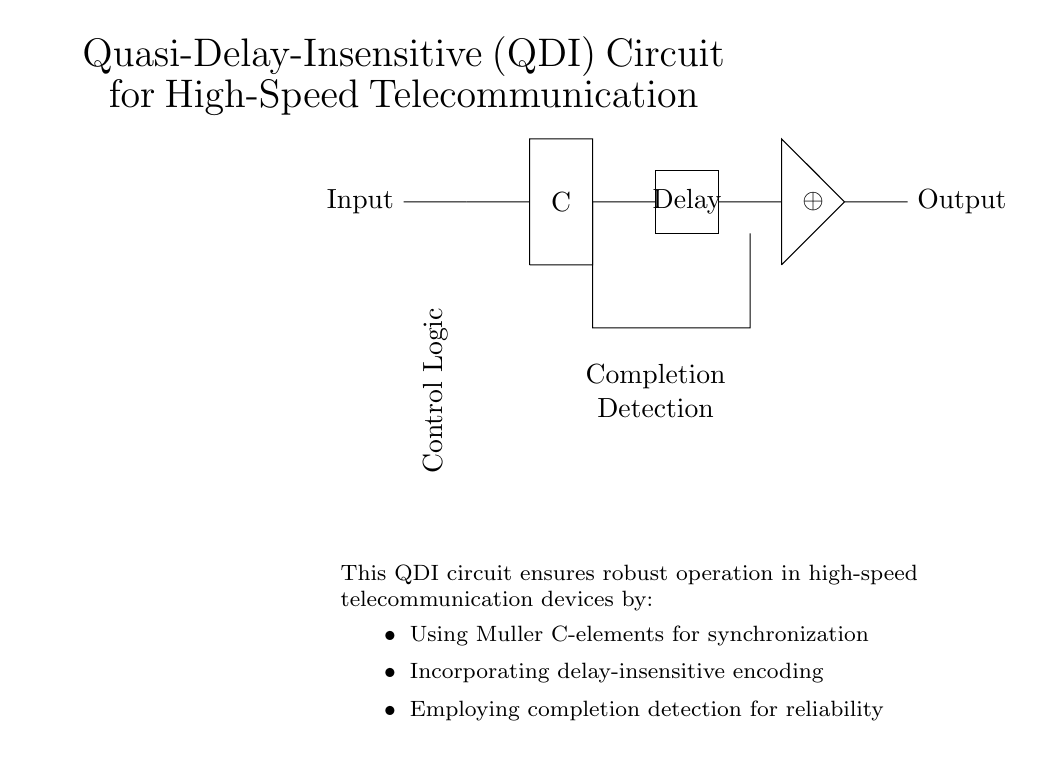What is the primary function of the Muller C-element in this circuit? The Muller C-element acts as a synchronization point for the circuit. It ensures that the output only changes when all inputs are stable, providing smooth operation in asynchronous environments.
Answer: Synchronization What type of gate is used in the circuit? The circuit employs an XOR gate, which is indicated by the symbol seen between the delay and output. This type of gate is often used for comparison or toggle operations in digital logic circuits.
Answer: XOR What is the role of the 'Delay' element in the circuit? The 'Delay' element is responsible for introducing a time delay in the signal path, ensuring that signals can propagate without causing race conditions, which is crucial in high-speed communication.
Answer: Time delay How many main components are clearly identified in the circuit? The diagram indicates three key components: the Muller C-element, the Delay element, and the XOR gate, each performing specific functions within the overall operation of the circuit.
Answer: Three What is the purpose of the feedback path in this QDI circuit? The feedback path is vital for completion detection and helps in stabilizing the state of the circuit, ensuring that transitions are properly managed, and allowing the system to confirm when operations are complete.
Answer: Completion detection Which connection represents the Input in the circuit? The circuit diagram starts with the line that feeds from the left side labeled 'Input,' connecting to the Muller C-element, indicating where data enters the system for processing.
Answer: Left side 